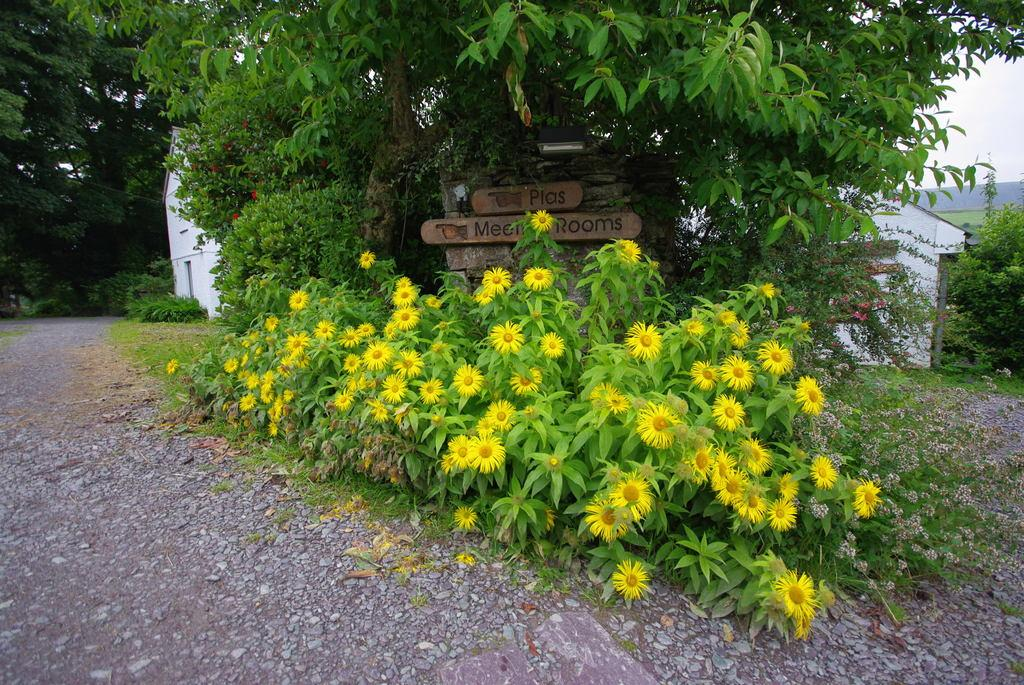What can be seen on the ground in the image? There are stones on the ground in the image. What type of signage is present in the image? There are name boards in the image. What type of vegetation is present in the image? There are trees and plants with flowers in the image. What type of structure is visible in the image? There is a house in the image. What can be seen in the background of the image? The grass and the sky are visible in the background of the image. Can you tell me how many sheep are in the flock in the image? There is no flock of sheep present in the image. What type of note is being offered to the person in the image? There is no person or note being offered in the image. 